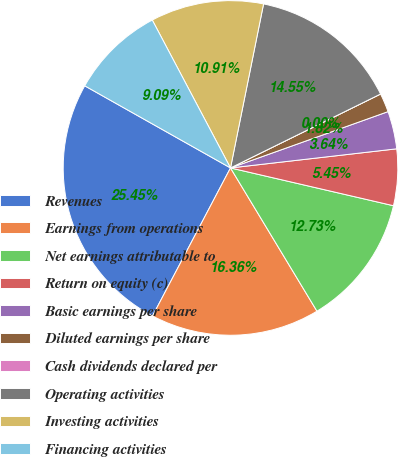Convert chart. <chart><loc_0><loc_0><loc_500><loc_500><pie_chart><fcel>Revenues<fcel>Earnings from operations<fcel>Net earnings attributable to<fcel>Return on equity (c)<fcel>Basic earnings per share<fcel>Diluted earnings per share<fcel>Cash dividends declared per<fcel>Operating activities<fcel>Investing activities<fcel>Financing activities<nl><fcel>25.45%<fcel>16.36%<fcel>12.73%<fcel>5.45%<fcel>3.64%<fcel>1.82%<fcel>0.0%<fcel>14.55%<fcel>10.91%<fcel>9.09%<nl></chart> 